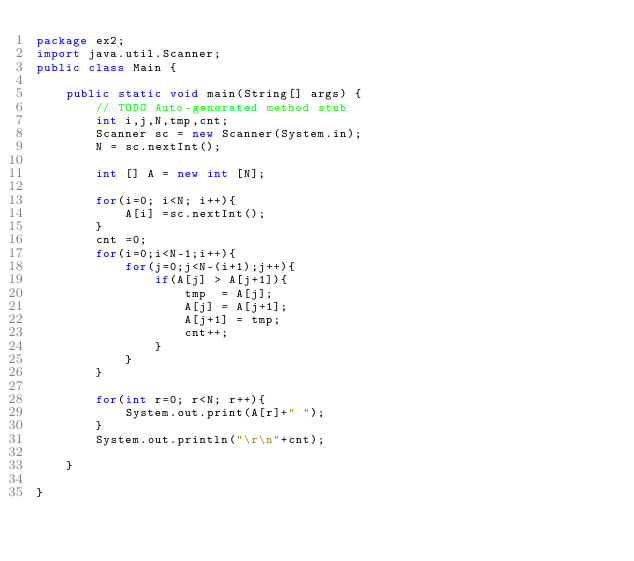Convert code to text. <code><loc_0><loc_0><loc_500><loc_500><_Java_>package ex2;
import java.util.Scanner;
public class Main {

	public static void main(String[] args) {
		// TODO Auto-generated method stub
		int i,j,N,tmp,cnt;
		Scanner sc = new Scanner(System.in);
		N = sc.nextInt();
	
		int [] A = new int [N];
		
		for(i=0; i<N; i++){
			A[i] =sc.nextInt();
		}
		cnt =0;
		for(i=0;i<N-1;i++){
			for(j=0;j<N-(i+1);j++){
				if(A[j] > A[j+1]){
					tmp  = A[j];
					A[j] = A[j+1];
					A[j+1] = tmp;
					cnt++;
				}
			}
		}
		
		for(int r=0; r<N; r++){
			System.out.print(A[r]+" ");
		}
		System.out.println("\r\n"+cnt);

	}

}

</code> 